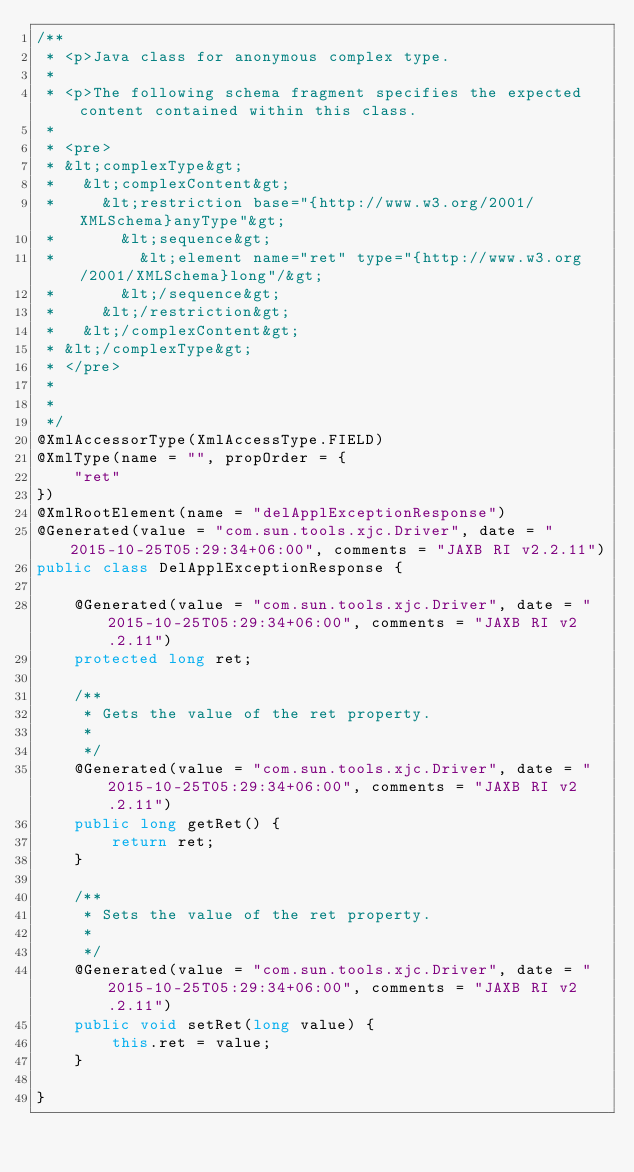Convert code to text. <code><loc_0><loc_0><loc_500><loc_500><_Java_>/**
 * <p>Java class for anonymous complex type.
 * 
 * <p>The following schema fragment specifies the expected content contained within this class.
 * 
 * <pre>
 * &lt;complexType&gt;
 *   &lt;complexContent&gt;
 *     &lt;restriction base="{http://www.w3.org/2001/XMLSchema}anyType"&gt;
 *       &lt;sequence&gt;
 *         &lt;element name="ret" type="{http://www.w3.org/2001/XMLSchema}long"/&gt;
 *       &lt;/sequence&gt;
 *     &lt;/restriction&gt;
 *   &lt;/complexContent&gt;
 * &lt;/complexType&gt;
 * </pre>
 * 
 * 
 */
@XmlAccessorType(XmlAccessType.FIELD)
@XmlType(name = "", propOrder = {
    "ret"
})
@XmlRootElement(name = "delApplExceptionResponse")
@Generated(value = "com.sun.tools.xjc.Driver", date = "2015-10-25T05:29:34+06:00", comments = "JAXB RI v2.2.11")
public class DelApplExceptionResponse {

    @Generated(value = "com.sun.tools.xjc.Driver", date = "2015-10-25T05:29:34+06:00", comments = "JAXB RI v2.2.11")
    protected long ret;

    /**
     * Gets the value of the ret property.
     * 
     */
    @Generated(value = "com.sun.tools.xjc.Driver", date = "2015-10-25T05:29:34+06:00", comments = "JAXB RI v2.2.11")
    public long getRet() {
        return ret;
    }

    /**
     * Sets the value of the ret property.
     * 
     */
    @Generated(value = "com.sun.tools.xjc.Driver", date = "2015-10-25T05:29:34+06:00", comments = "JAXB RI v2.2.11")
    public void setRet(long value) {
        this.ret = value;
    }

}
</code> 